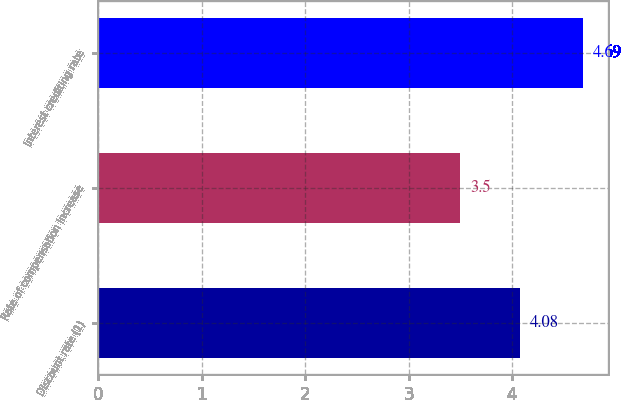Convert chart. <chart><loc_0><loc_0><loc_500><loc_500><bar_chart><fcel>Discount rate (1)<fcel>Rate of compensation increase<fcel>Interest crediting rate<nl><fcel>4.08<fcel>3.5<fcel>4.69<nl></chart> 